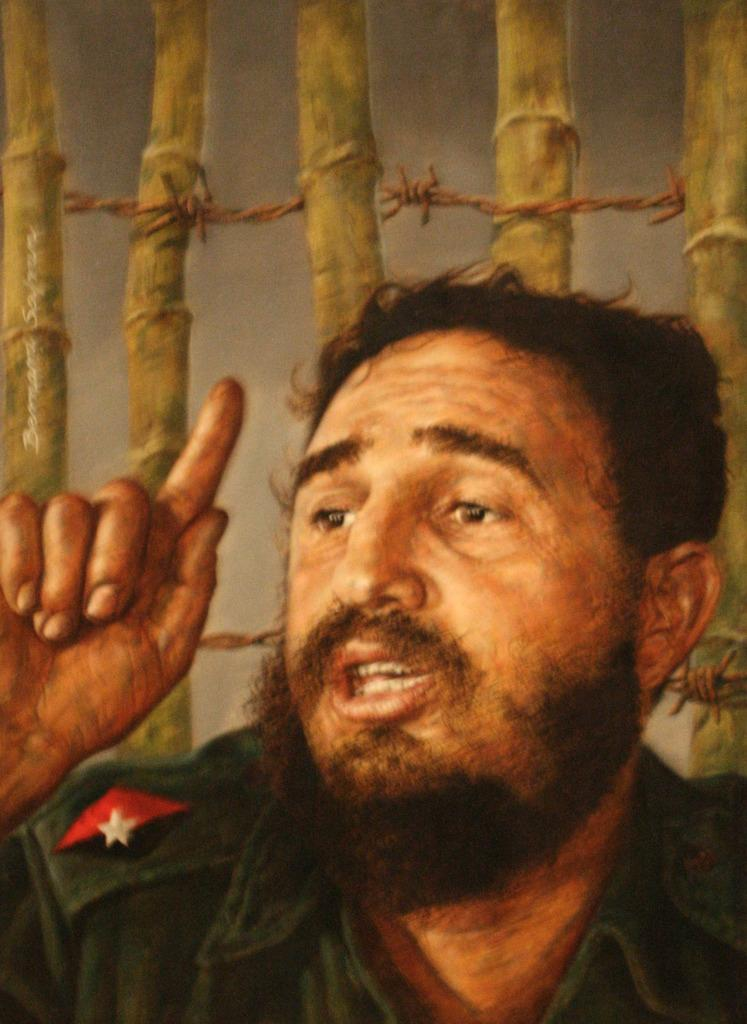What is depicted in the painting in the image? There is a painting of a man in the image. What is the man wearing in the painting? The man is wearing a green dress in the painting. What is the man doing with his hand in the painting? The man is showing his hand in the painting. Who is the man looking at in the painting? The man is looking at someone in the painting. What can be seen in the background of the painting? There are poles and twisted wires in the background of the painting. What type of medical advice is the man giving in the painting? There is no indication in the painting that the man is a doctor or giving medical advice. 